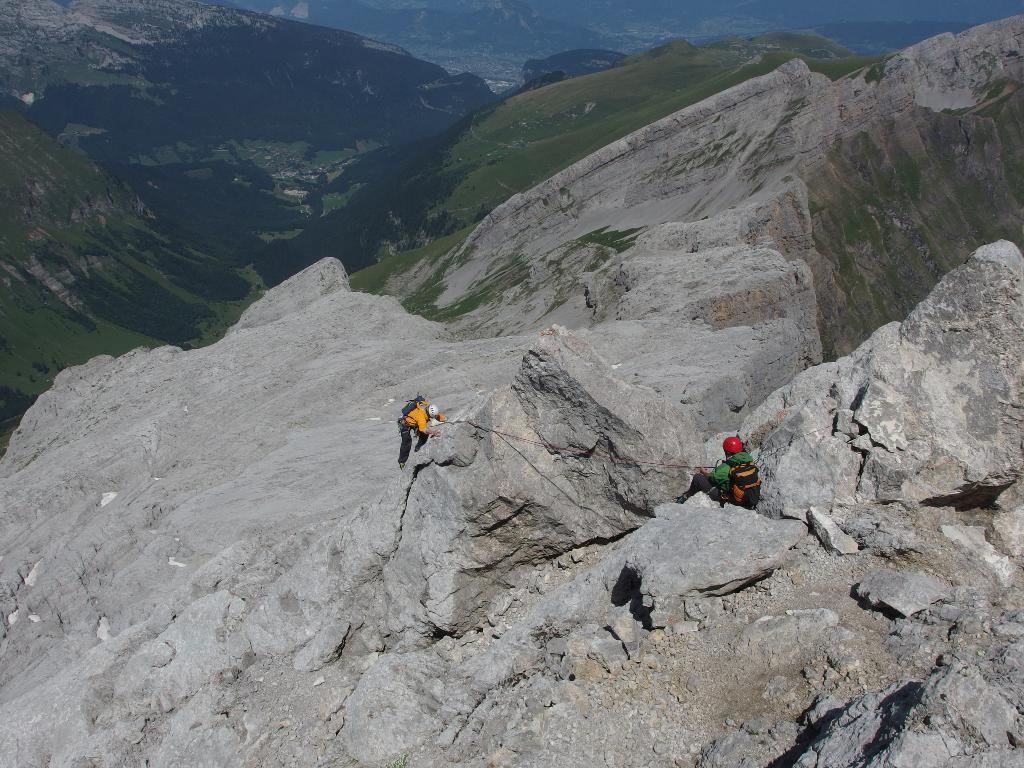How many people are in the image? There are two people in the image. What are the two people wearing on their heads? The two people are wearing helmets. What are the two people carrying in the image? The two people are carrying bags. What type of natural landscape can be seen in the image? There are hills visible in the image. What object is present in the image that might be used for climbing or securing? There is a rope in the image. What type of vegetation is visible in the image? There is grass visible in the image. How many frogs are hopping on the rope in the image? There are no frogs present in the image, and therefore no such activity can be observed. What type of dog is sitting on the grass in the image? There is no dog present in the image; it features two people wearing helmets, carrying bags, and standing near hills and a rope. 